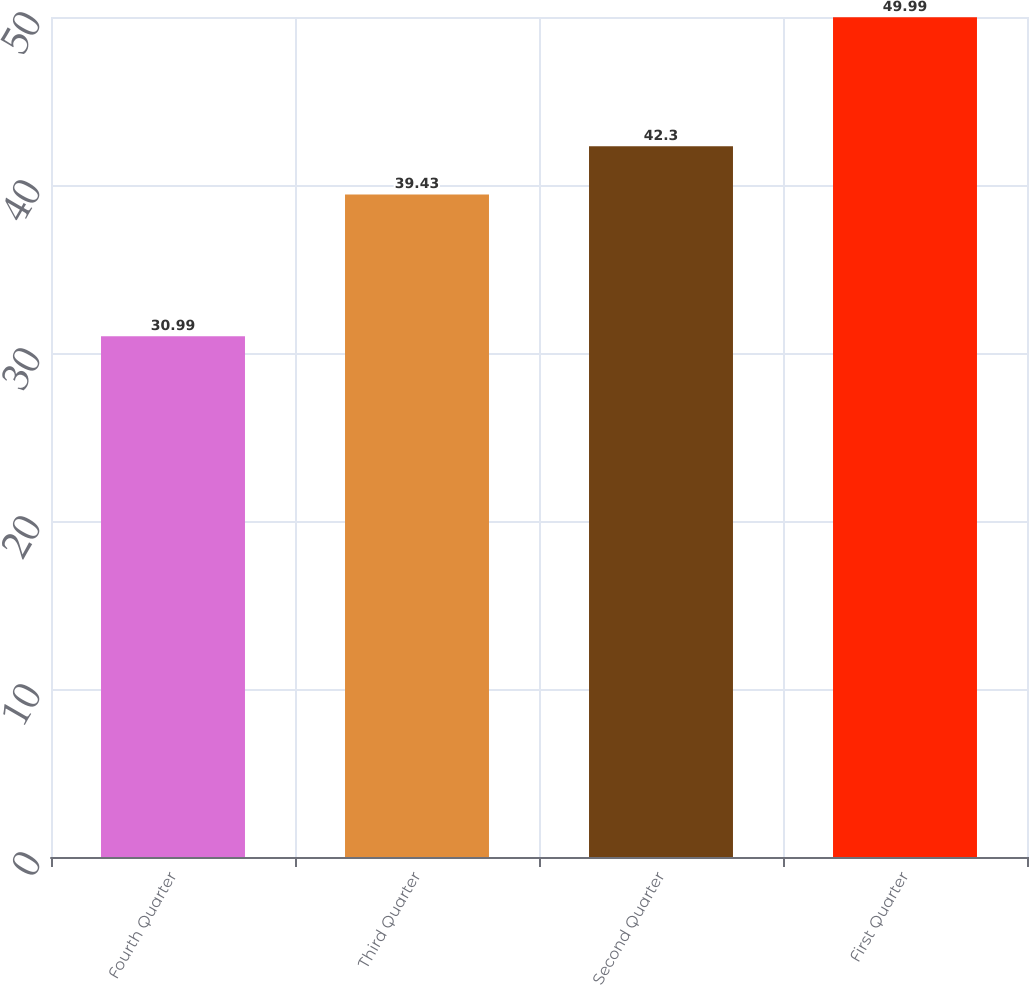Convert chart. <chart><loc_0><loc_0><loc_500><loc_500><bar_chart><fcel>Fourth Quarter<fcel>Third Quarter<fcel>Second Quarter<fcel>First Quarter<nl><fcel>30.99<fcel>39.43<fcel>42.3<fcel>49.99<nl></chart> 